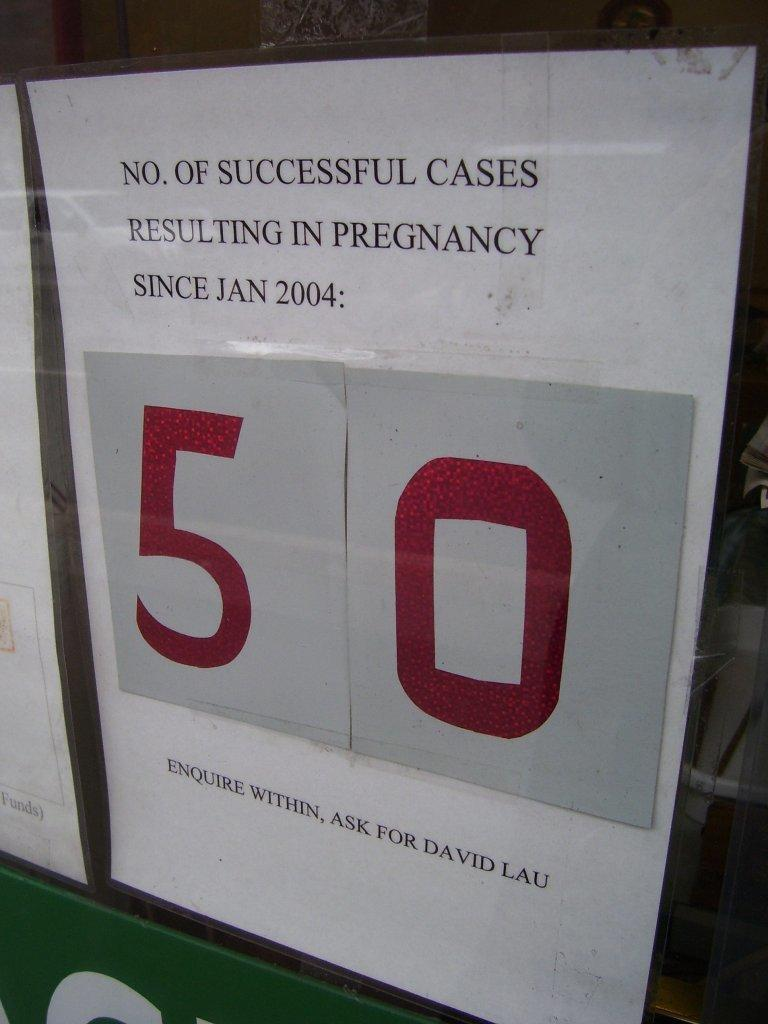<image>
Relay a brief, clear account of the picture shown. An advertisement regarding successful pregnancy cases since 2004. 